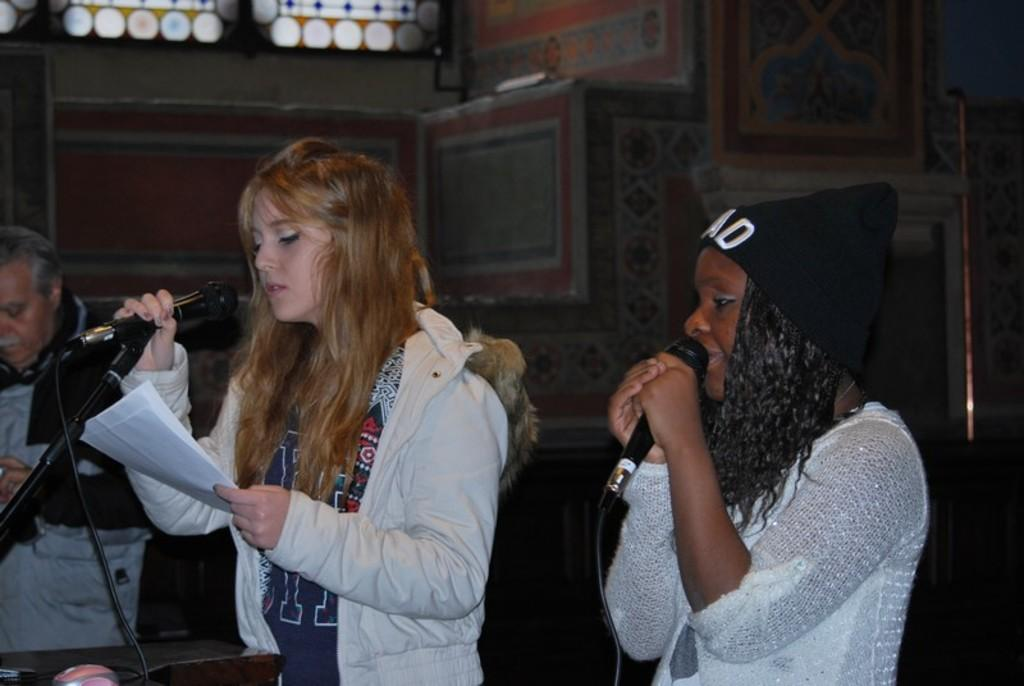How many people are in the image? There are three persons in the image. What are the two women holding? The two women are holding microphones. What is the center person holding? The center person is holding a paper. What can be seen in the background of the image? There is a wall, a glass window, and other objects visible in the background. What type of loaf can be seen on the table in the image? There is no loaf present in the image. Who is controlling the cars in the image? There are no cars or control mechanisms present in the image. 